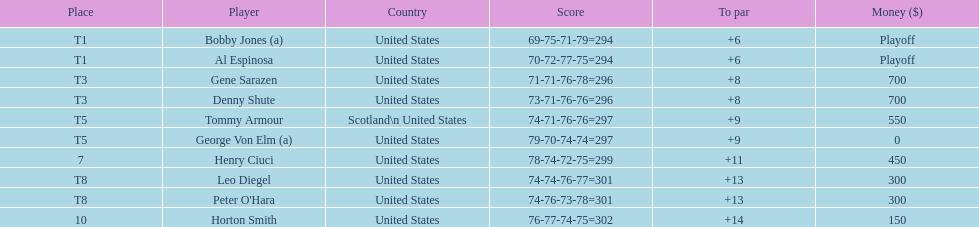How many players represented scotland? 1. 